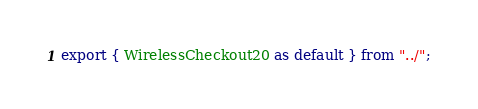Convert code to text. <code><loc_0><loc_0><loc_500><loc_500><_TypeScript_>export { WirelessCheckout20 as default } from "../";
</code> 